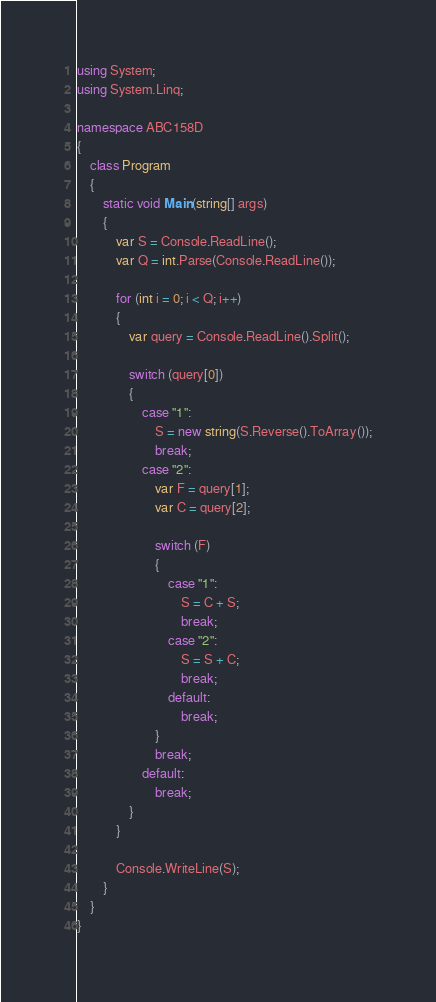Convert code to text. <code><loc_0><loc_0><loc_500><loc_500><_C#_>using System;
using System.Linq;

namespace ABC158D
{
    class Program
    {
        static void Main(string[] args)
        {
            var S = Console.ReadLine();
            var Q = int.Parse(Console.ReadLine());

            for (int i = 0; i < Q; i++)
            {
                var query = Console.ReadLine().Split();

                switch (query[0])
                {
                    case "1":
                        S = new string(S.Reverse().ToArray());
                        break;
                    case "2":
                        var F = query[1];
                        var C = query[2];

                        switch (F)
                        {
                            case "1":
                                S = C + S;
                                break;
                            case "2":
                                S = S + C;
                                break;
                            default:
                                break;
                        }
                        break;
                    default:
                        break;
                }
            }

            Console.WriteLine(S);
        }
    }
}
</code> 